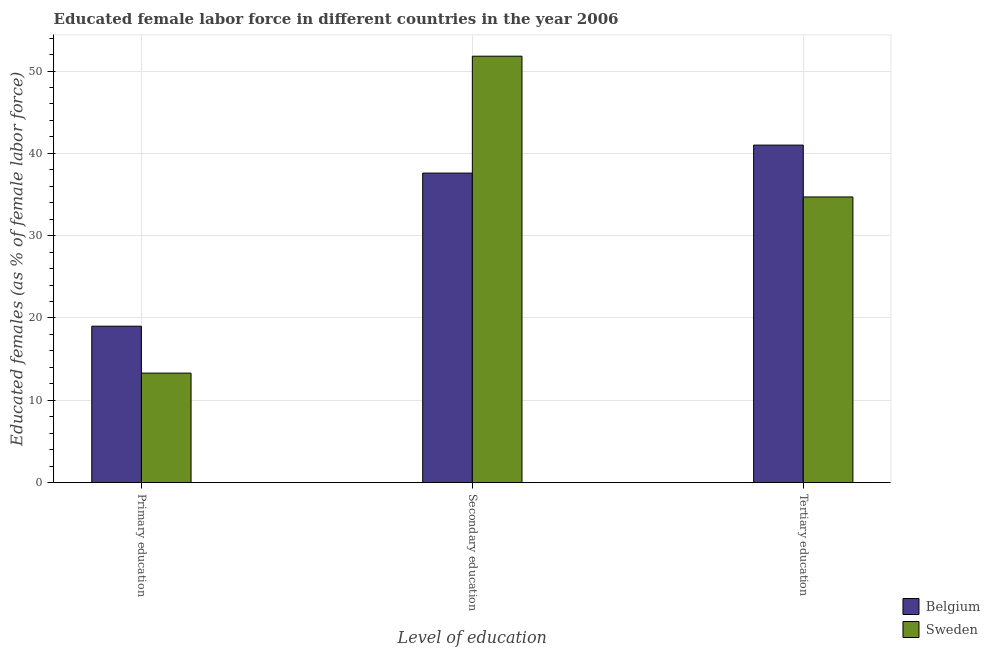How many different coloured bars are there?
Your answer should be very brief. 2. What is the percentage of female labor force who received tertiary education in Sweden?
Provide a succinct answer. 34.7. Across all countries, what is the maximum percentage of female labor force who received secondary education?
Keep it short and to the point. 51.8. Across all countries, what is the minimum percentage of female labor force who received secondary education?
Provide a short and direct response. 37.6. What is the total percentage of female labor force who received tertiary education in the graph?
Ensure brevity in your answer.  75.7. What is the difference between the percentage of female labor force who received secondary education in Belgium and that in Sweden?
Your answer should be very brief. -14.2. What is the difference between the percentage of female labor force who received secondary education in Sweden and the percentage of female labor force who received primary education in Belgium?
Offer a very short reply. 32.8. What is the average percentage of female labor force who received primary education per country?
Offer a terse response. 16.15. What is the difference between the percentage of female labor force who received secondary education and percentage of female labor force who received tertiary education in Sweden?
Your response must be concise. 17.1. What is the ratio of the percentage of female labor force who received primary education in Belgium to that in Sweden?
Your answer should be very brief. 1.43. Is the percentage of female labor force who received secondary education in Sweden less than that in Belgium?
Provide a short and direct response. No. What is the difference between the highest and the second highest percentage of female labor force who received primary education?
Offer a very short reply. 5.7. What is the difference between the highest and the lowest percentage of female labor force who received secondary education?
Your response must be concise. 14.2. In how many countries, is the percentage of female labor force who received primary education greater than the average percentage of female labor force who received primary education taken over all countries?
Offer a terse response. 1. Is the sum of the percentage of female labor force who received secondary education in Sweden and Belgium greater than the maximum percentage of female labor force who received tertiary education across all countries?
Ensure brevity in your answer.  Yes. Are all the bars in the graph horizontal?
Give a very brief answer. No. What is the difference between two consecutive major ticks on the Y-axis?
Your answer should be very brief. 10. Does the graph contain any zero values?
Provide a succinct answer. No. Where does the legend appear in the graph?
Your response must be concise. Bottom right. How many legend labels are there?
Make the answer very short. 2. What is the title of the graph?
Ensure brevity in your answer.  Educated female labor force in different countries in the year 2006. What is the label or title of the X-axis?
Offer a very short reply. Level of education. What is the label or title of the Y-axis?
Ensure brevity in your answer.  Educated females (as % of female labor force). What is the Educated females (as % of female labor force) of Belgium in Primary education?
Provide a succinct answer. 19. What is the Educated females (as % of female labor force) of Sweden in Primary education?
Your response must be concise. 13.3. What is the Educated females (as % of female labor force) of Belgium in Secondary education?
Your answer should be very brief. 37.6. What is the Educated females (as % of female labor force) in Sweden in Secondary education?
Your response must be concise. 51.8. What is the Educated females (as % of female labor force) of Belgium in Tertiary education?
Offer a very short reply. 41. What is the Educated females (as % of female labor force) of Sweden in Tertiary education?
Your answer should be compact. 34.7. Across all Level of education, what is the maximum Educated females (as % of female labor force) in Belgium?
Give a very brief answer. 41. Across all Level of education, what is the maximum Educated females (as % of female labor force) of Sweden?
Give a very brief answer. 51.8. Across all Level of education, what is the minimum Educated females (as % of female labor force) of Sweden?
Provide a short and direct response. 13.3. What is the total Educated females (as % of female labor force) of Belgium in the graph?
Your answer should be compact. 97.6. What is the total Educated females (as % of female labor force) in Sweden in the graph?
Keep it short and to the point. 99.8. What is the difference between the Educated females (as % of female labor force) in Belgium in Primary education and that in Secondary education?
Make the answer very short. -18.6. What is the difference between the Educated females (as % of female labor force) of Sweden in Primary education and that in Secondary education?
Make the answer very short. -38.5. What is the difference between the Educated females (as % of female labor force) in Sweden in Primary education and that in Tertiary education?
Keep it short and to the point. -21.4. What is the difference between the Educated females (as % of female labor force) of Belgium in Secondary education and that in Tertiary education?
Your response must be concise. -3.4. What is the difference between the Educated females (as % of female labor force) of Belgium in Primary education and the Educated females (as % of female labor force) of Sweden in Secondary education?
Give a very brief answer. -32.8. What is the difference between the Educated females (as % of female labor force) of Belgium in Primary education and the Educated females (as % of female labor force) of Sweden in Tertiary education?
Provide a succinct answer. -15.7. What is the difference between the Educated females (as % of female labor force) in Belgium in Secondary education and the Educated females (as % of female labor force) in Sweden in Tertiary education?
Keep it short and to the point. 2.9. What is the average Educated females (as % of female labor force) in Belgium per Level of education?
Offer a terse response. 32.53. What is the average Educated females (as % of female labor force) of Sweden per Level of education?
Offer a terse response. 33.27. What is the difference between the Educated females (as % of female labor force) in Belgium and Educated females (as % of female labor force) in Sweden in Secondary education?
Your answer should be very brief. -14.2. What is the ratio of the Educated females (as % of female labor force) of Belgium in Primary education to that in Secondary education?
Your answer should be compact. 0.51. What is the ratio of the Educated females (as % of female labor force) in Sweden in Primary education to that in Secondary education?
Provide a succinct answer. 0.26. What is the ratio of the Educated females (as % of female labor force) in Belgium in Primary education to that in Tertiary education?
Your response must be concise. 0.46. What is the ratio of the Educated females (as % of female labor force) in Sweden in Primary education to that in Tertiary education?
Keep it short and to the point. 0.38. What is the ratio of the Educated females (as % of female labor force) of Belgium in Secondary education to that in Tertiary education?
Your answer should be compact. 0.92. What is the ratio of the Educated females (as % of female labor force) in Sweden in Secondary education to that in Tertiary education?
Ensure brevity in your answer.  1.49. What is the difference between the highest and the second highest Educated females (as % of female labor force) in Sweden?
Make the answer very short. 17.1. What is the difference between the highest and the lowest Educated females (as % of female labor force) of Belgium?
Your answer should be very brief. 22. What is the difference between the highest and the lowest Educated females (as % of female labor force) in Sweden?
Provide a short and direct response. 38.5. 